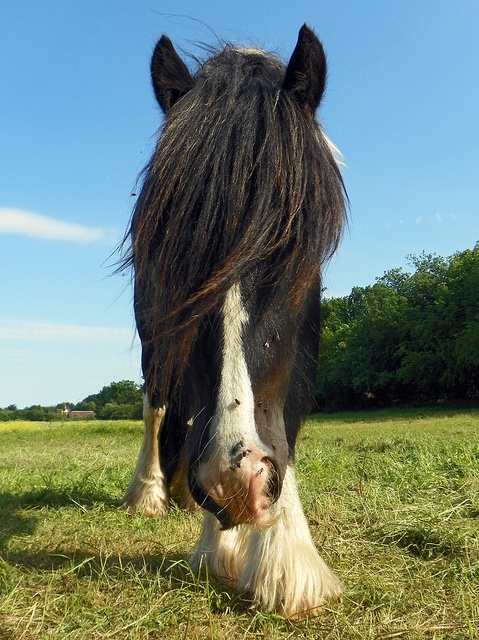Describe the objects in this image and their specific colors. I can see a horse in lightblue, black, and gray tones in this image. 